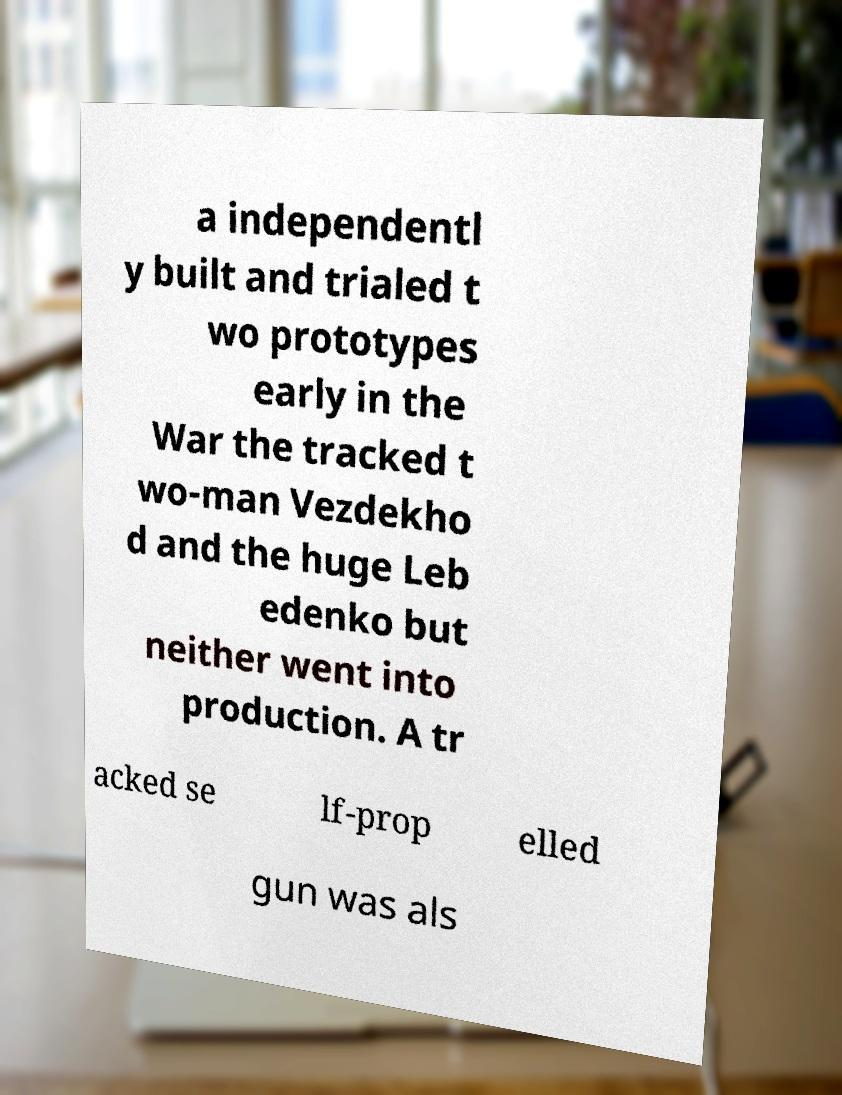Can you read and provide the text displayed in the image?This photo seems to have some interesting text. Can you extract and type it out for me? a independentl y built and trialed t wo prototypes early in the War the tracked t wo-man Vezdekho d and the huge Leb edenko but neither went into production. A tr acked se lf-prop elled gun was als 